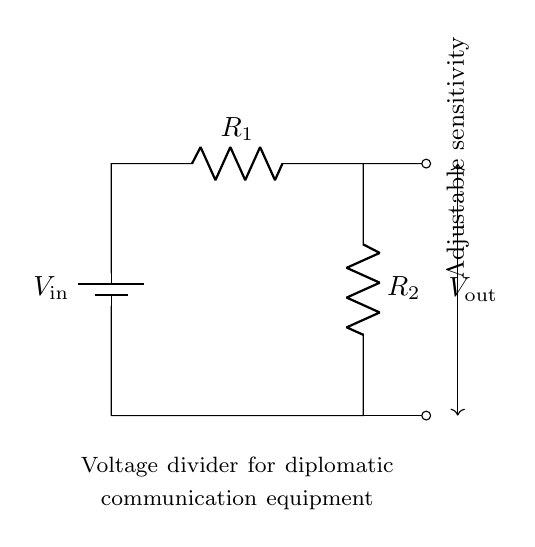What are the components in this circuit? The circuit contains a battery, two resistors, and connection lines. The battery provides the input voltage, while the resistors are used to create the voltage division.
Answer: battery, resistors What is the function of the resistors in this circuit? The resistors create a voltage divider, adjusting the output voltage based on their values, which is crucial for setting the sensitivity of the equipment.
Answer: voltage divider What does the output voltage represent in this circuit? The output voltage represents the voltage across the second resistor, which can be adjusted for different sensitivity levels in the diplomatic communication equipment.
Answer: adjusted voltage How are the resistors arranged in the circuit? The resistors are arranged in series, meaning the total resistance is the sum of both resistances, which influences the voltage division between them.
Answer: series What is the relationship between the input voltage and the output voltage? The output voltage is a fraction of the input voltage, determined by the values of the resistors, according to the formula V out = Vin * (R2 / (R1 + R2)).
Answer: fraction What is the purpose of the adjustable sensitivity in this circuit? The adjustable sensitivity allows for fine-tuning the output voltage, accommodating different signal strengths in the communication equipment, which is key for maintaining effective diplomatic communication.
Answer: fine-tuning 